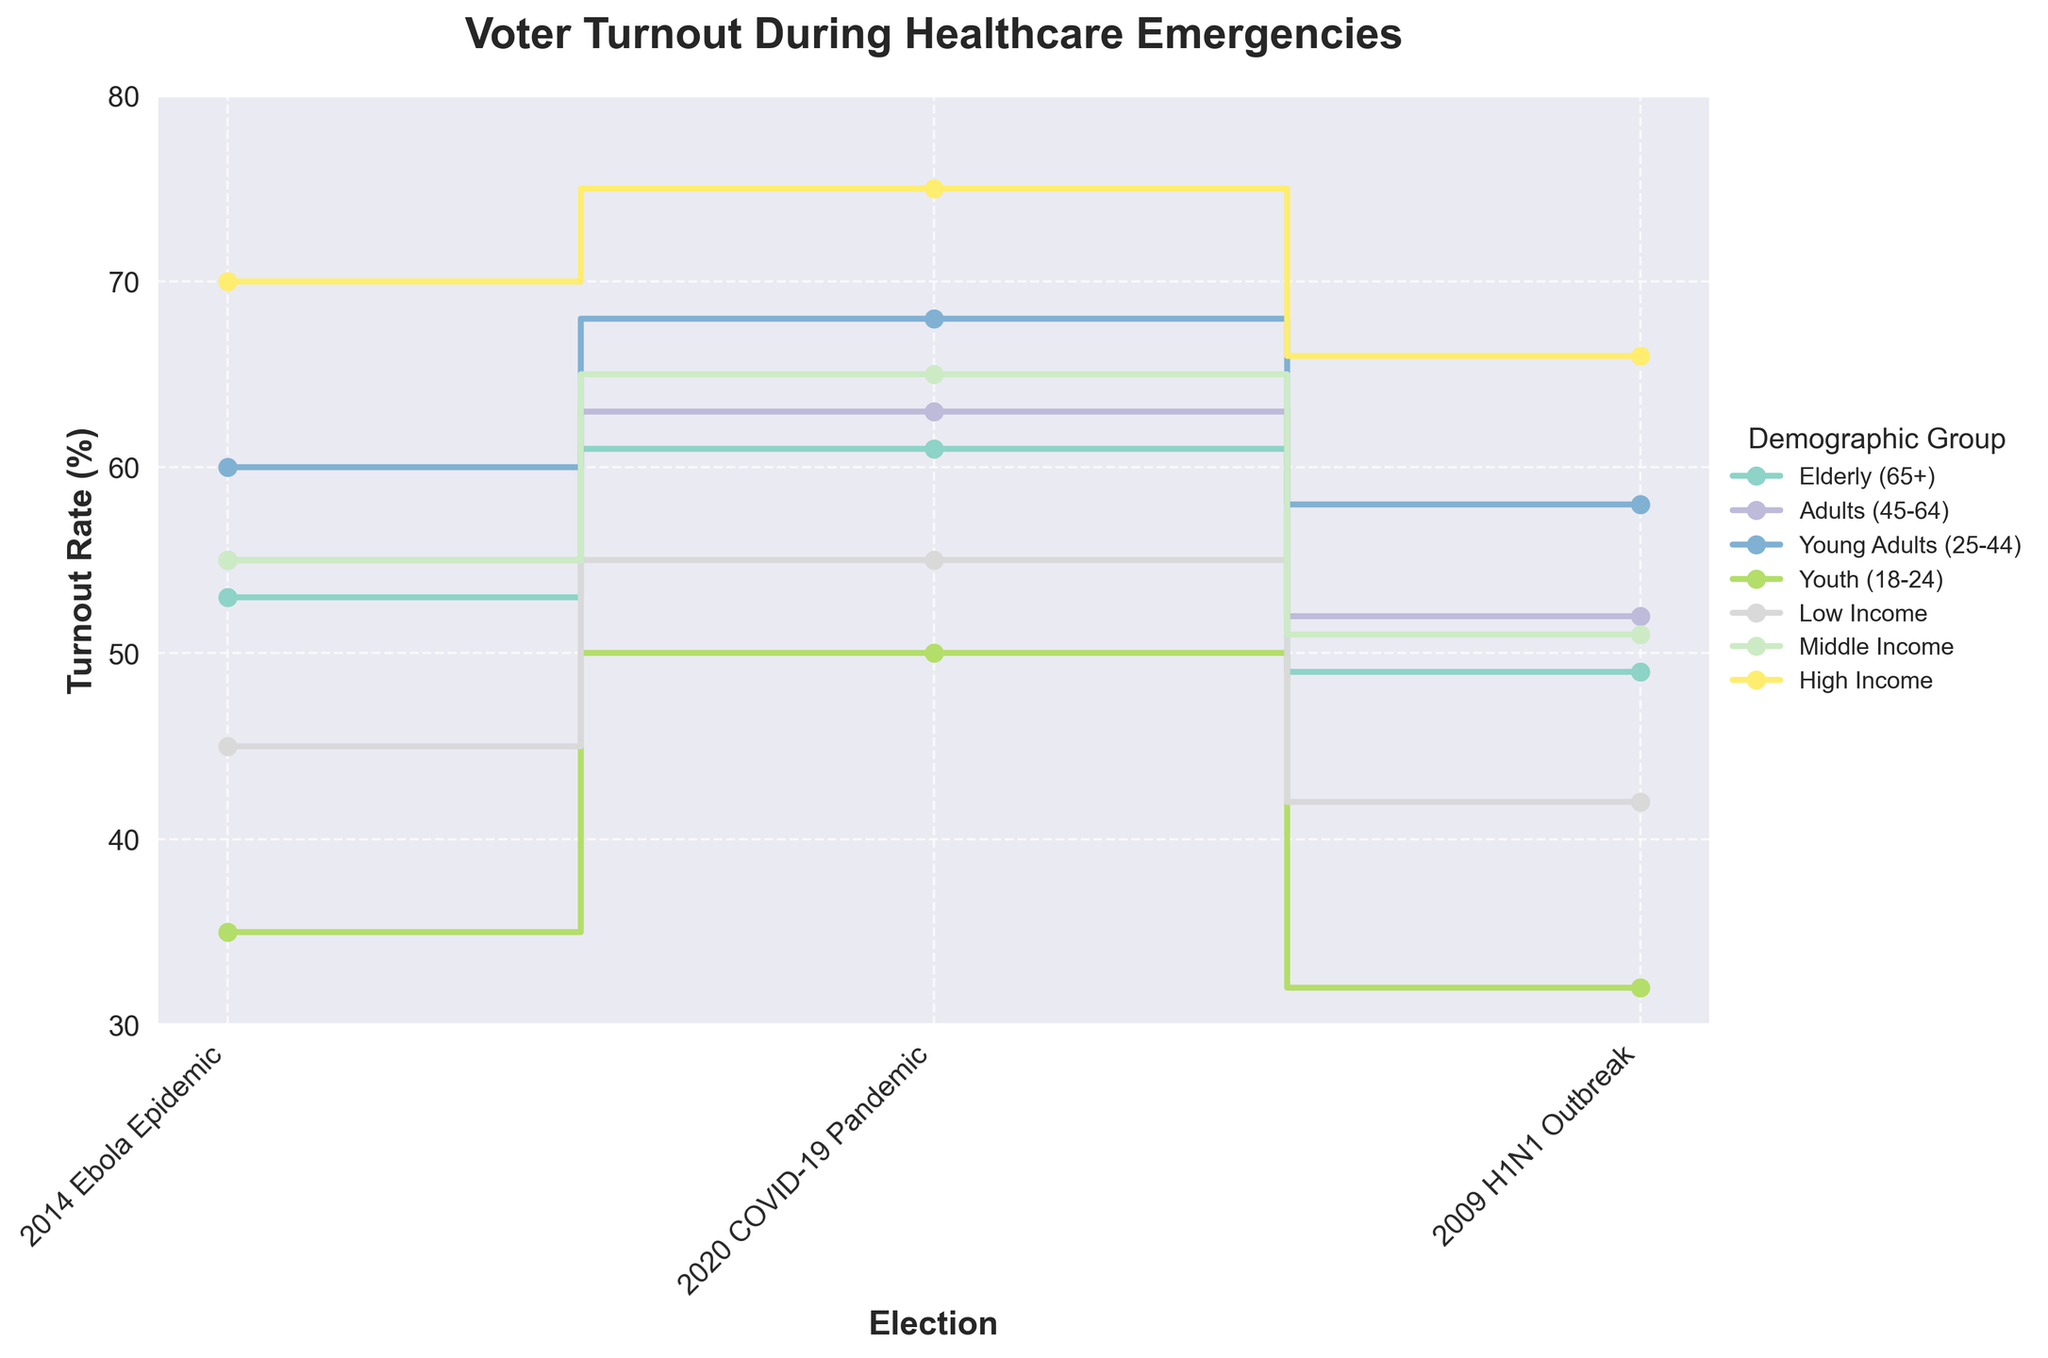Which demographic group had the highest voter turnout during the 2014 Ebola Epidemic? To determine this, look at the turnout rates for each demographic during the 2014 Ebola Epidemic. The highest turnout rate is 70%, associated with the High Income group.
Answer: High Income Which election year had the lowest voter turnout for the Youth demographic? Review the turnout rates for the Youth demographic in each election year. The lowest turnout rate is 32% during the 2009 H1N1 Outbreak.
Answer: 2009 H1N1 Outbreak How did the voter turnout rate for the Elderly demographic change from the 2009 H1N1 Outbreak to the 2020 COVID-19 Pandemic? The Elderly turnout rate was 49% during the 2009 H1N1 Outbreak and increased to 61% during the 2020 COVID-19 Pandemic. The change was an increase of 12%.
Answer: Increased by 12% Which demographic saw the largest increase in voter turnout from the 2014 Ebola Epidemic to the 2020 COVID-19 Pandemic? Calculate the differences for each demographic group between the years 2014 and 2020. High Income saw the largest increase, from 70% to 75%, which is a 5% increase.
Answer: High Income In which election year did Middle Income voters have a higher turnout rate than Low Income voters but a lower turnout rate than High Income voters? Compare the Middle Income turnout rates to those of Low and High Income for each election year. In all three years (2009, 2014, and 2020), this condition holds true.
Answer: All years Rank the voter turnout rates for each demographic group during the 2020 COVID-19 Pandemic from highest to lowest. List the turnout rates for 2020 by demographic and order them: High Income (75%), Young Adults (68%), Middle Income (65%), Adults (63%), Elderly (61%), Low Income (55%), Youth (50%).
Answer: High Income > Young Adults > Middle Income > Adults > Elderly > Low Income > Youth Did the Low Income demographic ever achieve a higher voter turnout rate than the Youth demographic across any of the displayed healthcare emergencies? Compare the turnout rates of Low Income and Youth for each election. Low Income turnout was always higher than Youth turnout in 2009, 2014, and 2020.
Answer: Yes What is the average voter turnout rate for Adults (45-64) across all three healthcare emergencies? Add the turnout rates for Adults (45-64): (52% + 55% + 63%) and divide by 3. The sum is 170, so the average is 170/3 = 56.67%.
Answer: 56.67% Which election had the most significant turnout decrease for the High Income demographic compared to the previous election? Compare the turnout changes for High Income across the elections. No election has a decrease as 66% (2009) < 70% (2014) < 75% (2020). All are increases.
Answer: None 